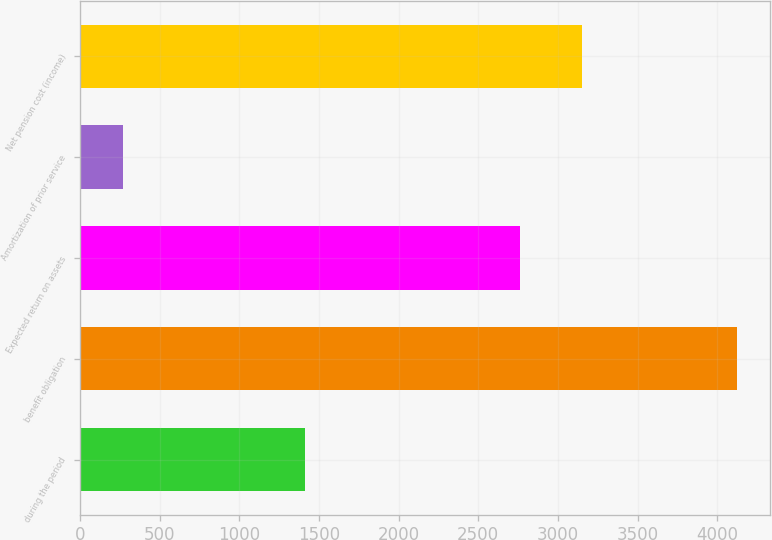Convert chart to OTSL. <chart><loc_0><loc_0><loc_500><loc_500><bar_chart><fcel>during the period<fcel>benefit obligation<fcel>Expected return on assets<fcel>Amortization of prior service<fcel>Net pension cost (income)<nl><fcel>1414<fcel>4126<fcel>2763<fcel>269<fcel>3148.7<nl></chart> 